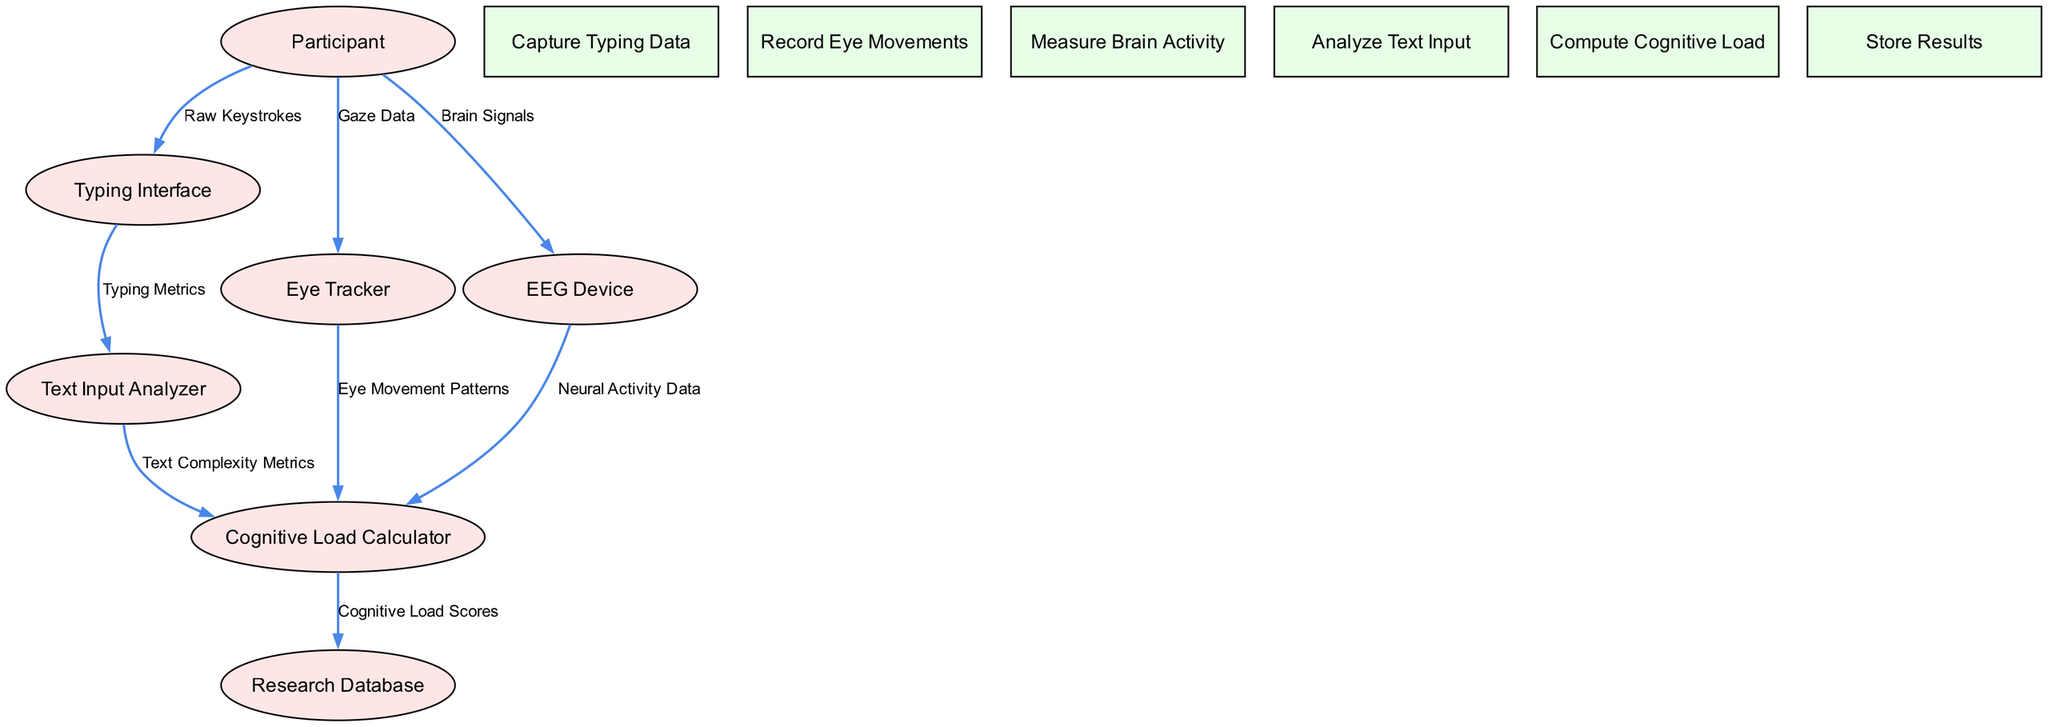What is the first entity in the diagram? The first entity listed in the diagram is the "Participant," which is the starting point for the data flow in the cognitive load assessment process.
Answer: Participant How many processes are shown in the diagram? By counting the items listed in the "processes" section of the diagram, there are a total of six distinct processes involved in the cognitive load assessment.
Answer: 6 What type of device records eye movements? The device responsible for recording eye movements in this diagram is the "Eye Tracker," identified specifically in the flow from the Participant to the Eye Tracker.
Answer: Eye Tracker Which process directly analyzes typing metrics? The process that directly analyzes typing metrics is the "Text Input Analyzer," which receives data from the Typing Interface to perform this analysis.
Answer: Text Input Analyzer Which data flow comes from the EEG Device to the Cognitive Load Calculator? The data flow from the EEG Device to the Cognitive Load Calculator consists of "Neural Activity Data," which is crucial for assessing cognitive load.
Answer: Neural Activity Data What is the end point for the cognitive load scores calculated in the diagram? The ultimate destination for the calculated cognitive load scores is the "Research Database," where the results are stored for further analysis and reference.
Answer: Research Database How many data flows are there in total? Upon reviewing the data flows listed, there are a total of seven distinct data flows connecting various entities and processes in the diagram.
Answer: 7 Which entity provides raw keystrokes to the Typing Interface? The entity providing raw keystrokes to the Typing Interface is the "Participant," who interacts with the interface by typing.
Answer: Participant What type of patterns does the Cognitive Load Calculator utilize from the Eye Tracker? The Cognitive Load Calculator utilizes "Eye Movement Patterns" from the Eye Tracker to compute cognitive load based on visual attention data.
Answer: Eye Movement Patterns 